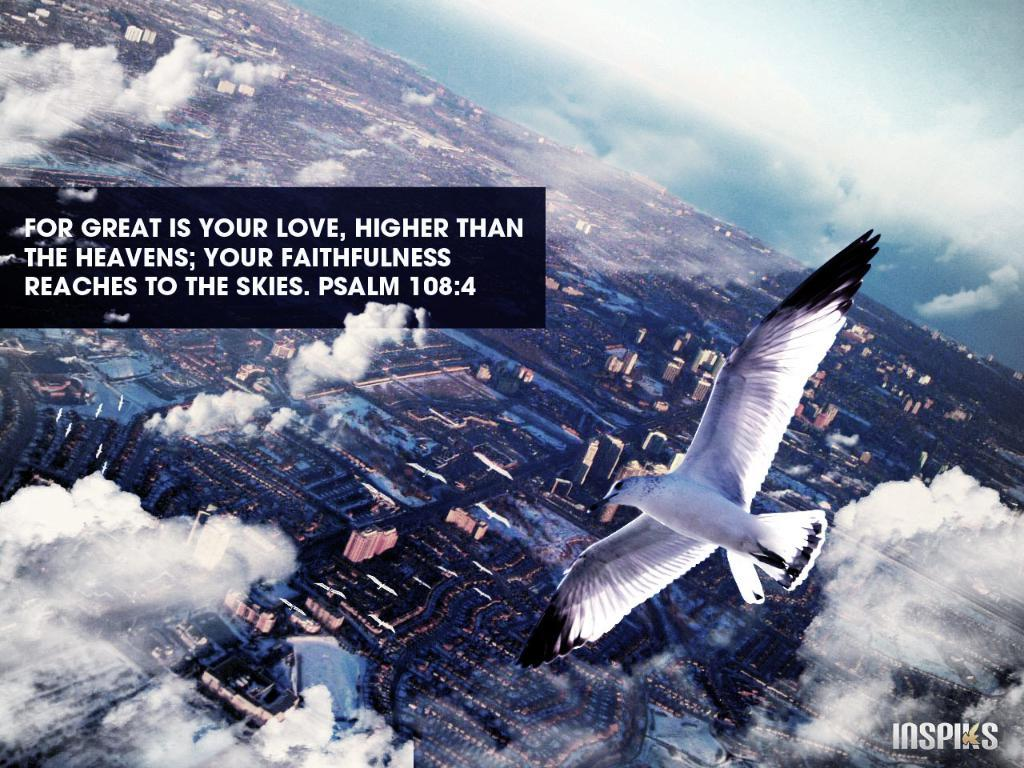What can be seen in the sky in the image? There are clouds in the image, and a bird is flying in the sky. What is present on the left side of the image? There is text on the left side of the image. Is there any additional information or branding in the image? Yes, there is a watermark in the bottom right-hand side of the image. What is the rate at which the celery is growing in the image? There is no celery present in the image, so it is not possible to determine the rate at which it might be growing. How many birds are flying in the image? The image only shows one bird flying in the sky. 